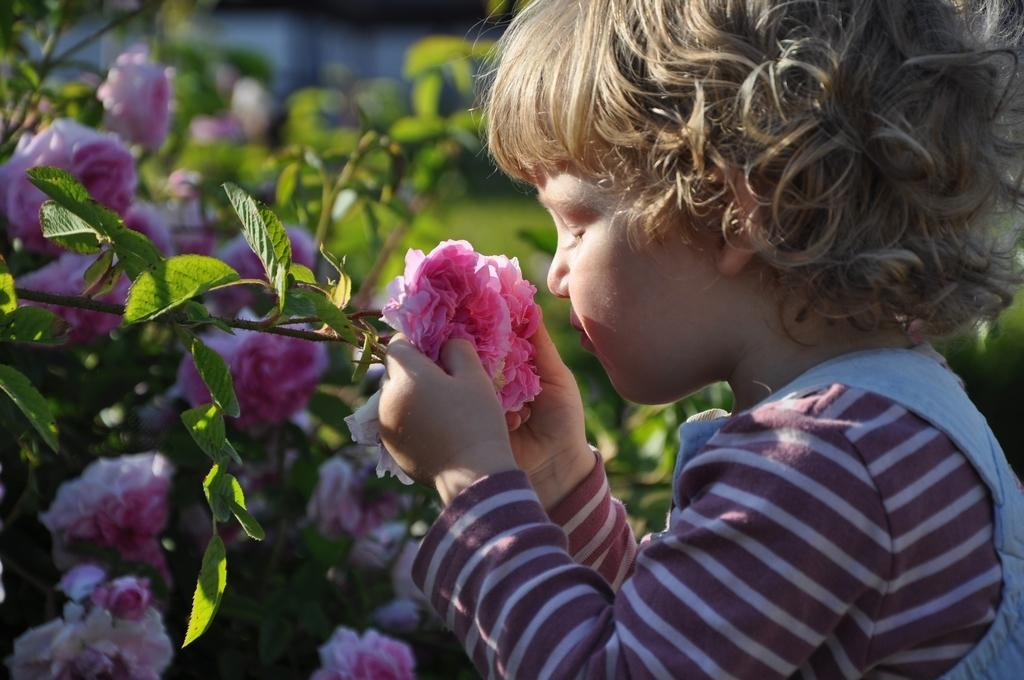Where is the kid located in the image? The kid is on the right side of the image. What is the kid holding in the image? The kid is holding a flower. What type of plants can be seen in the image? There are plants with flowers on the left side of the image. How would you describe the background of the image? The background of the image is blurred. What type of plastic material can be seen in the image? There is no plastic material present in the image. How does the light affect the visibility of the kid in the image? The provided facts do not mention any information about the lighting conditions in the image, so it is impossible to determine how the light affects the visibility of the kid. 